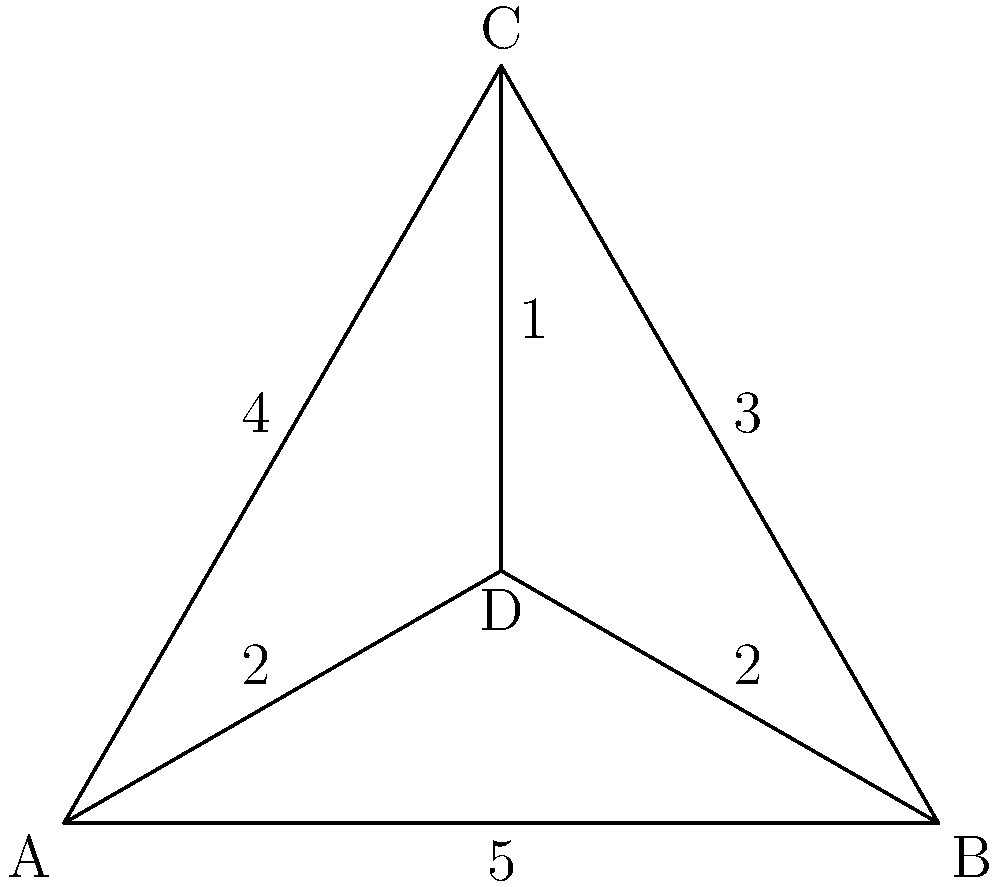In designing an accessible digital product, you need to optimize the network topology for data transfer between four components (A, B, C, and D). The edges represent data transfer paths, and the weights indicate the transfer time in milliseconds. What is the minimum spanning tree weight that ensures all components are connected while minimizing total transfer time? To find the minimum spanning tree weight, we'll use Kruskal's algorithm:

1. Sort edges by weight in ascending order:
   CD (1), AD (2), BD (2), BC (3), AC (4), AB (5)

2. Add edges to the tree, skipping those that form cycles:
   a) Add CD (1)
   b) Add AD (2)
   c) Add BD (2)
   d) Skip BC (3) as it forms a cycle
   e) Skip AC (4) as it forms a cycle
   f) Skip AB (5) as it forms a cycle

3. The minimum spanning tree consists of edges:
   CD (1), AD (2), BD (2)

4. Calculate the total weight:
   $$1 + 2 + 2 = 5$$

Therefore, the minimum spanning tree weight is 5 milliseconds.
Answer: 5 milliseconds 